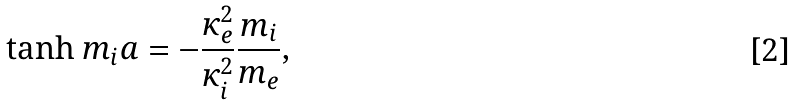<formula> <loc_0><loc_0><loc_500><loc_500>\tanh m _ { i } a = - \frac { \kappa ^ { 2 } _ { e } } { \kappa ^ { 2 } _ { i } } \frac { m _ { i } } { m _ { e } } ,</formula> 